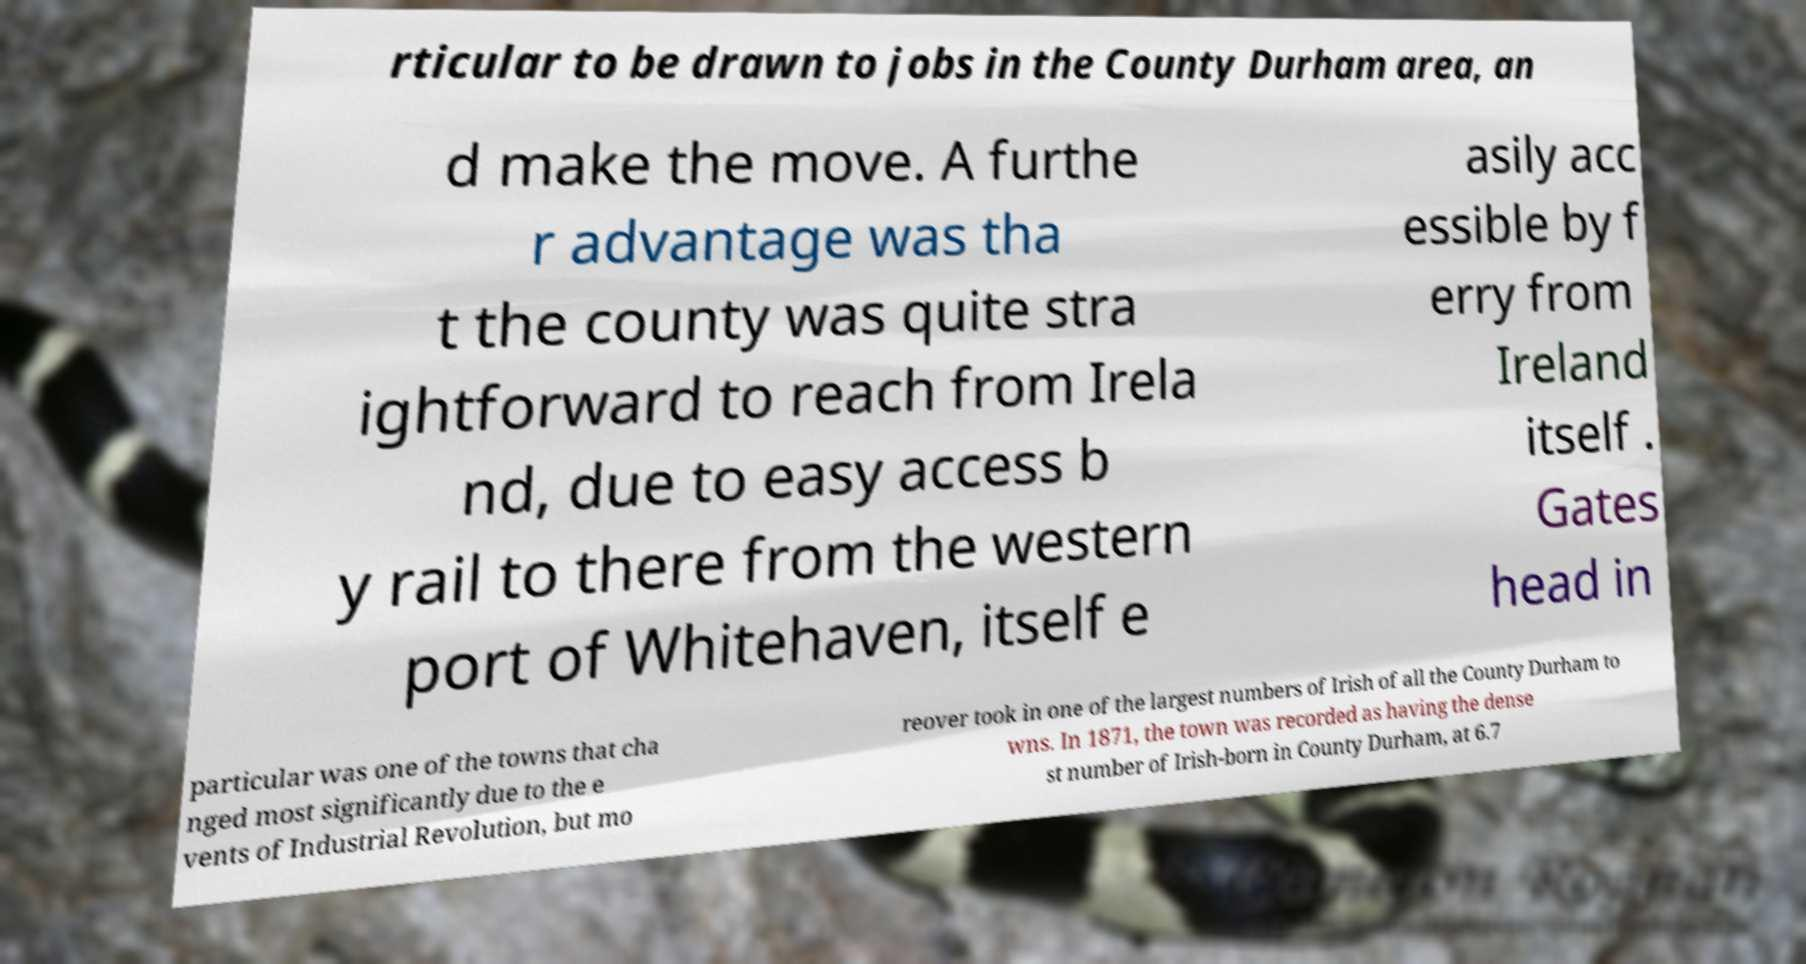Could you extract and type out the text from this image? rticular to be drawn to jobs in the County Durham area, an d make the move. A furthe r advantage was tha t the county was quite stra ightforward to reach from Irela nd, due to easy access b y rail to there from the western port of Whitehaven, itself e asily acc essible by f erry from Ireland itself . Gates head in particular was one of the towns that cha nged most significantly due to the e vents of Industrial Revolution, but mo reover took in one of the largest numbers of Irish of all the County Durham to wns. In 1871, the town was recorded as having the dense st number of Irish-born in County Durham, at 6.7 